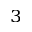<formula> <loc_0><loc_0><loc_500><loc_500>_ { 3 }</formula> 